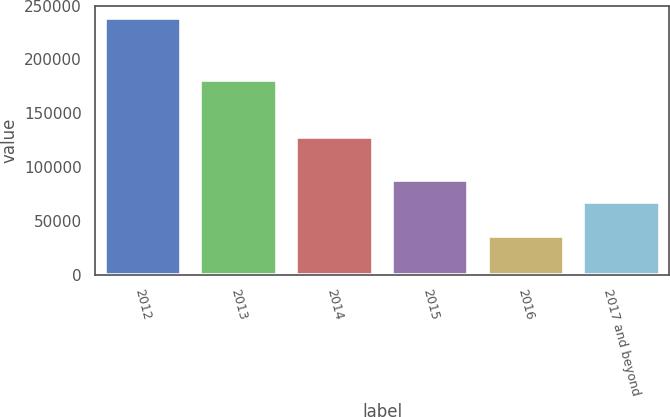<chart> <loc_0><loc_0><loc_500><loc_500><bar_chart><fcel>2012<fcel>2013<fcel>2014<fcel>2015<fcel>2016<fcel>2017 and beyond<nl><fcel>238167<fcel>181044<fcel>128063<fcel>87916.5<fcel>35942<fcel>67694<nl></chart> 